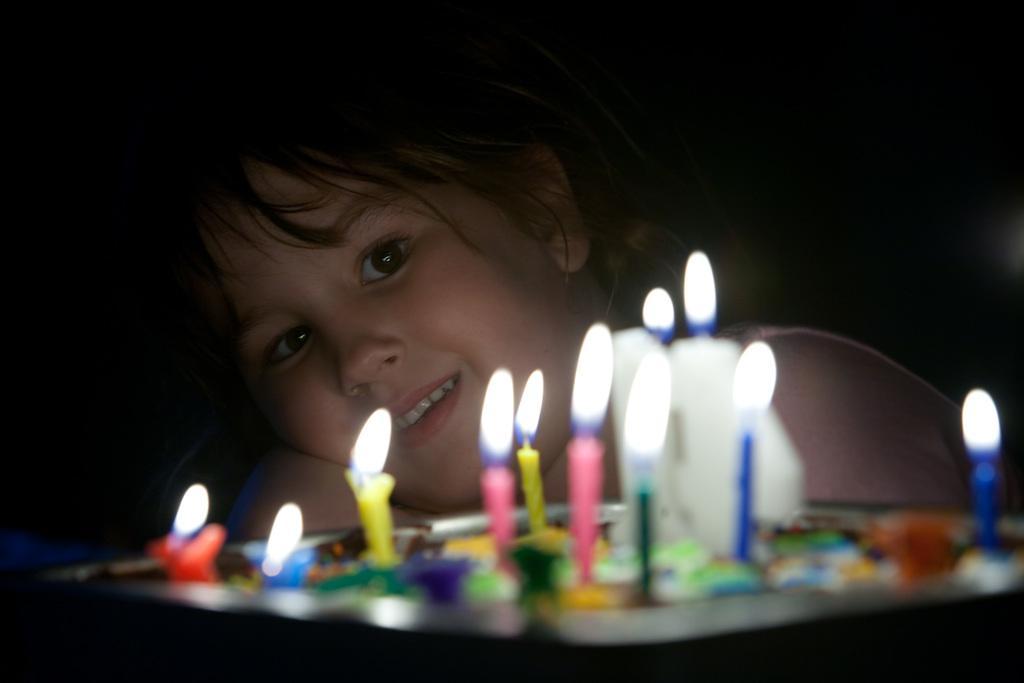How would you summarize this image in a sentence or two? In the image in the center we can see one plate. In plate,we can see few different color candles. In the background there is a girl. She is smiling,which we can see on her face. 